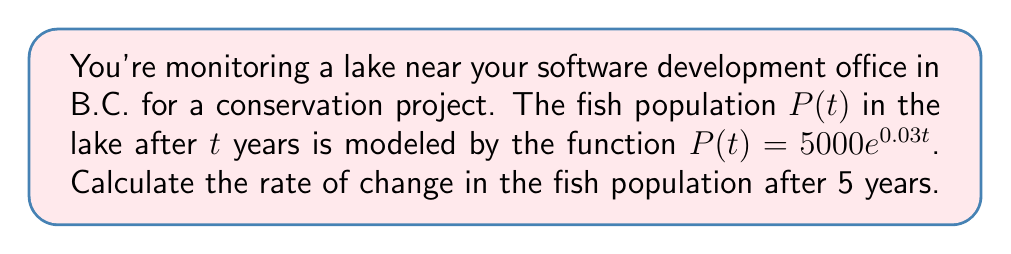What is the answer to this math problem? To find the rate of change in the fish population after 5 years, we need to calculate the derivative of $P(t)$ and evaluate it at $t=5$. Let's break this down step-by-step:

1) The given function is $P(t) = 5000e^{0.03t}$

2) To find the derivative, we use the chain rule:
   $$\frac{d}{dt}[P(t)] = 5000 \cdot \frac{d}{dt}[e^{0.03t}]$$
   $$\frac{d}{dt}[P(t)] = 5000 \cdot 0.03e^{0.03t}$$
   $$\frac{d}{dt}[P(t)] = 150e^{0.03t}$$

3) This derivative represents the instantaneous rate of change of the fish population at any time $t$.

4) To find the rate of change after 5 years, we evaluate the derivative at $t=5$:
   $$\frac{d}{dt}[P(5)] = 150e^{0.03(5)}$$
   $$\frac{d}{dt}[P(5)] = 150e^{0.15}$$

5) Calculate this value:
   $$\frac{d}{dt}[P(5)] \approx 150 \cdot 1.1618 \approx 174.27$$

Therefore, after 5 years, the fish population is increasing at a rate of approximately 174.27 fish per year.
Answer: 174.27 fish per year 